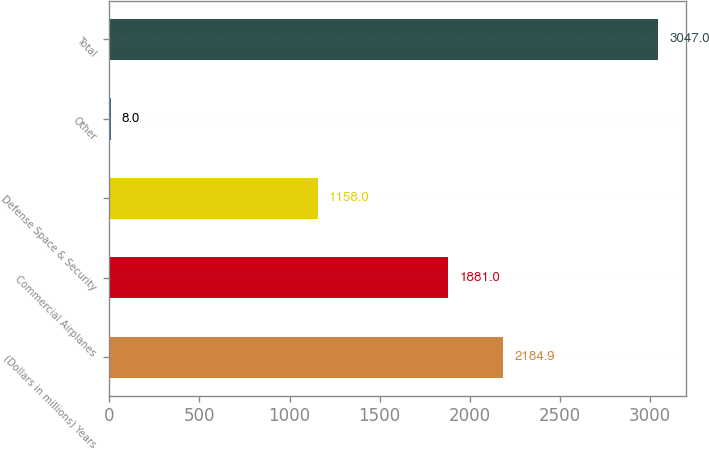Convert chart to OTSL. <chart><loc_0><loc_0><loc_500><loc_500><bar_chart><fcel>(Dollars in millions) Years<fcel>Commercial Airplanes<fcel>Defense Space & Security<fcel>Other<fcel>Total<nl><fcel>2184.9<fcel>1881<fcel>1158<fcel>8<fcel>3047<nl></chart> 